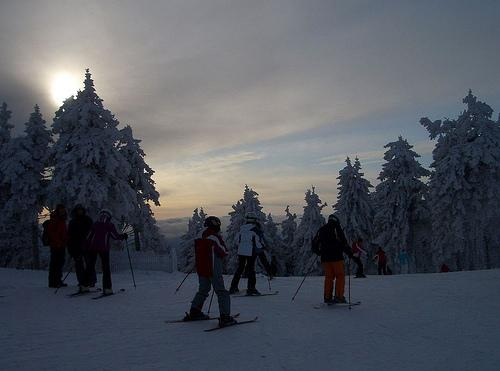What is touching the snow? skis 